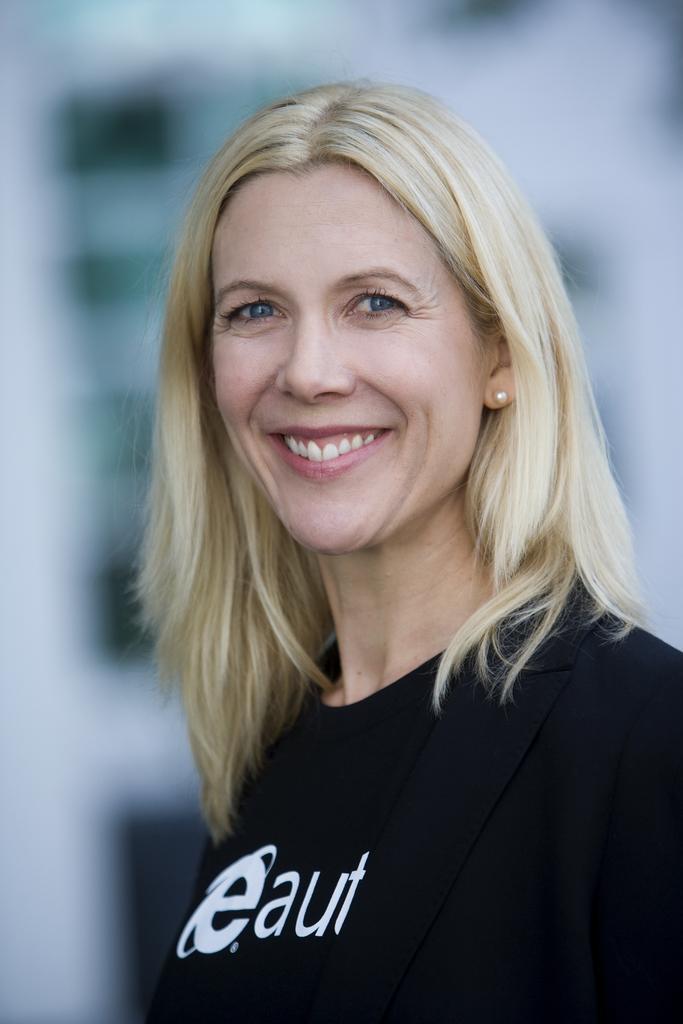Describe this image in one or two sentences. In picture we can see a woman who is wearing earring and black t-shirt. She is smiling. 